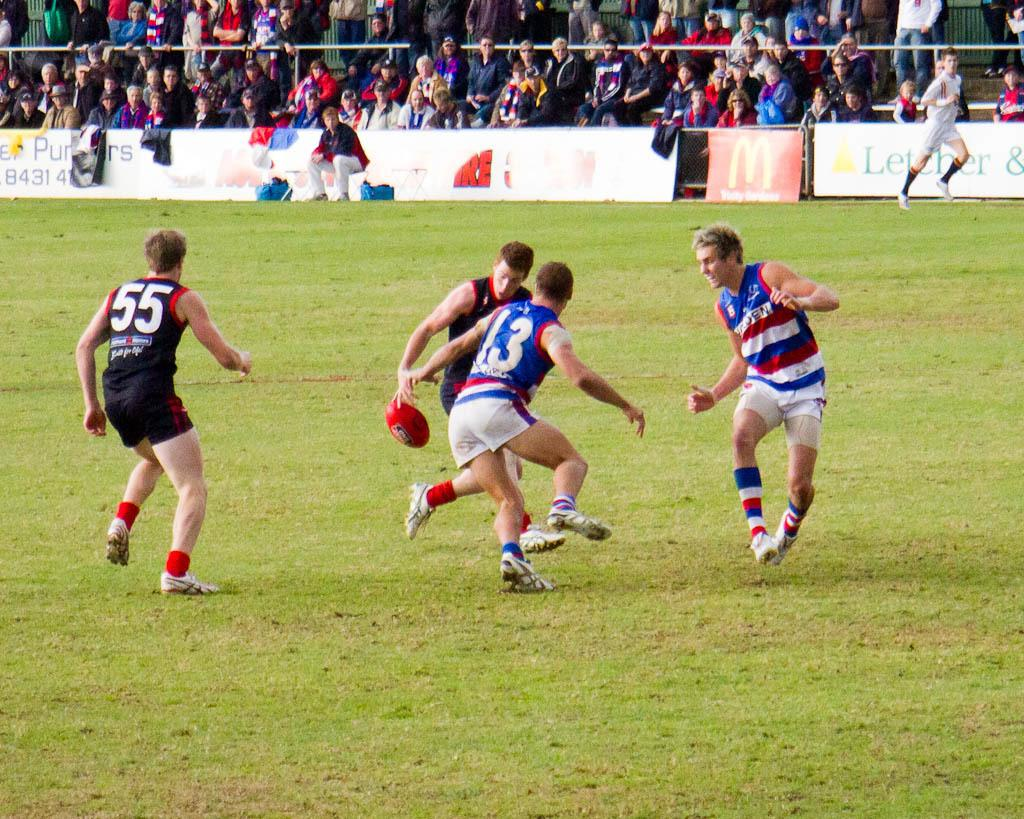<image>
Summarize the visual content of the image. players 13 and 55 are both going after the ball 